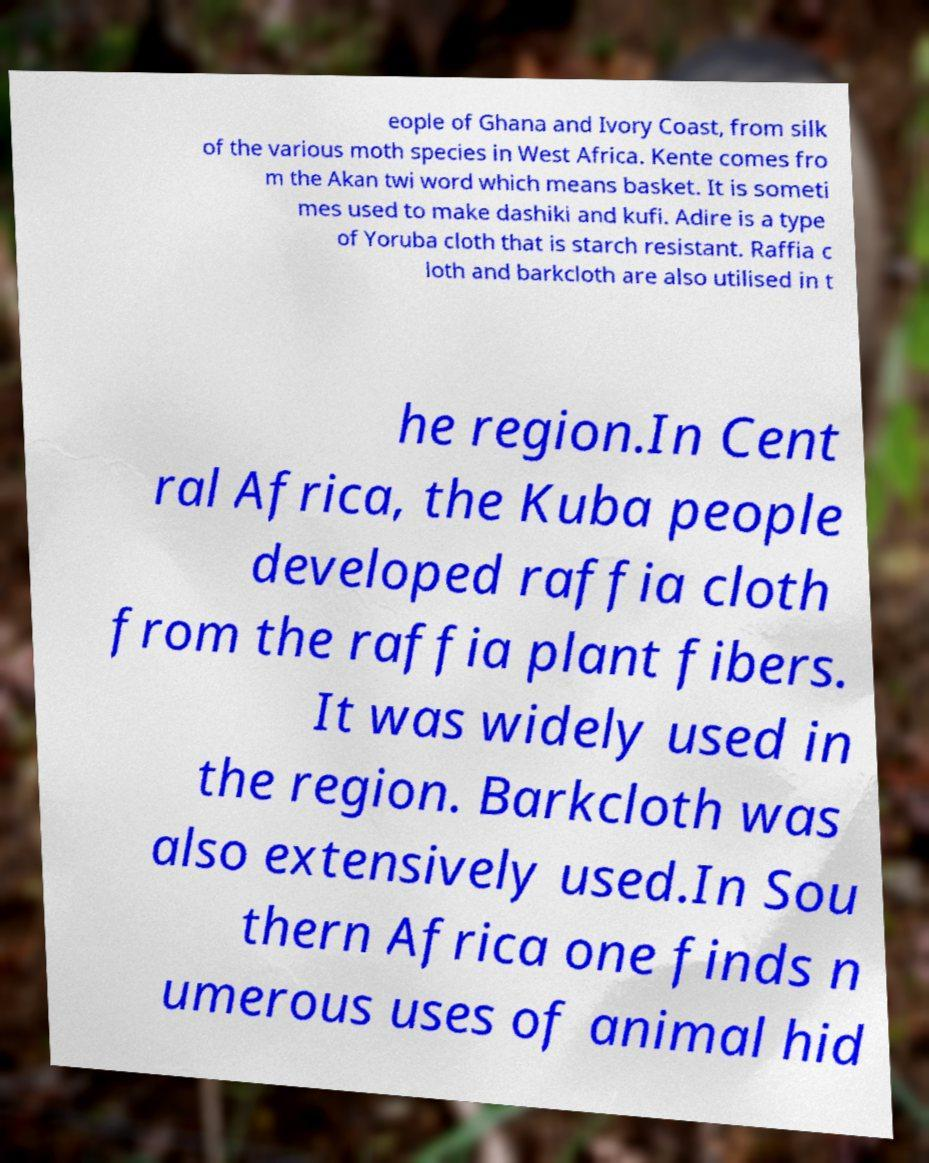Please read and relay the text visible in this image. What does it say? eople of Ghana and Ivory Coast, from silk of the various moth species in West Africa. Kente comes fro m the Akan twi word which means basket. It is someti mes used to make dashiki and kufi. Adire is a type of Yoruba cloth that is starch resistant. Raffia c loth and barkcloth are also utilised in t he region.In Cent ral Africa, the Kuba people developed raffia cloth from the raffia plant fibers. It was widely used in the region. Barkcloth was also extensively used.In Sou thern Africa one finds n umerous uses of animal hid 